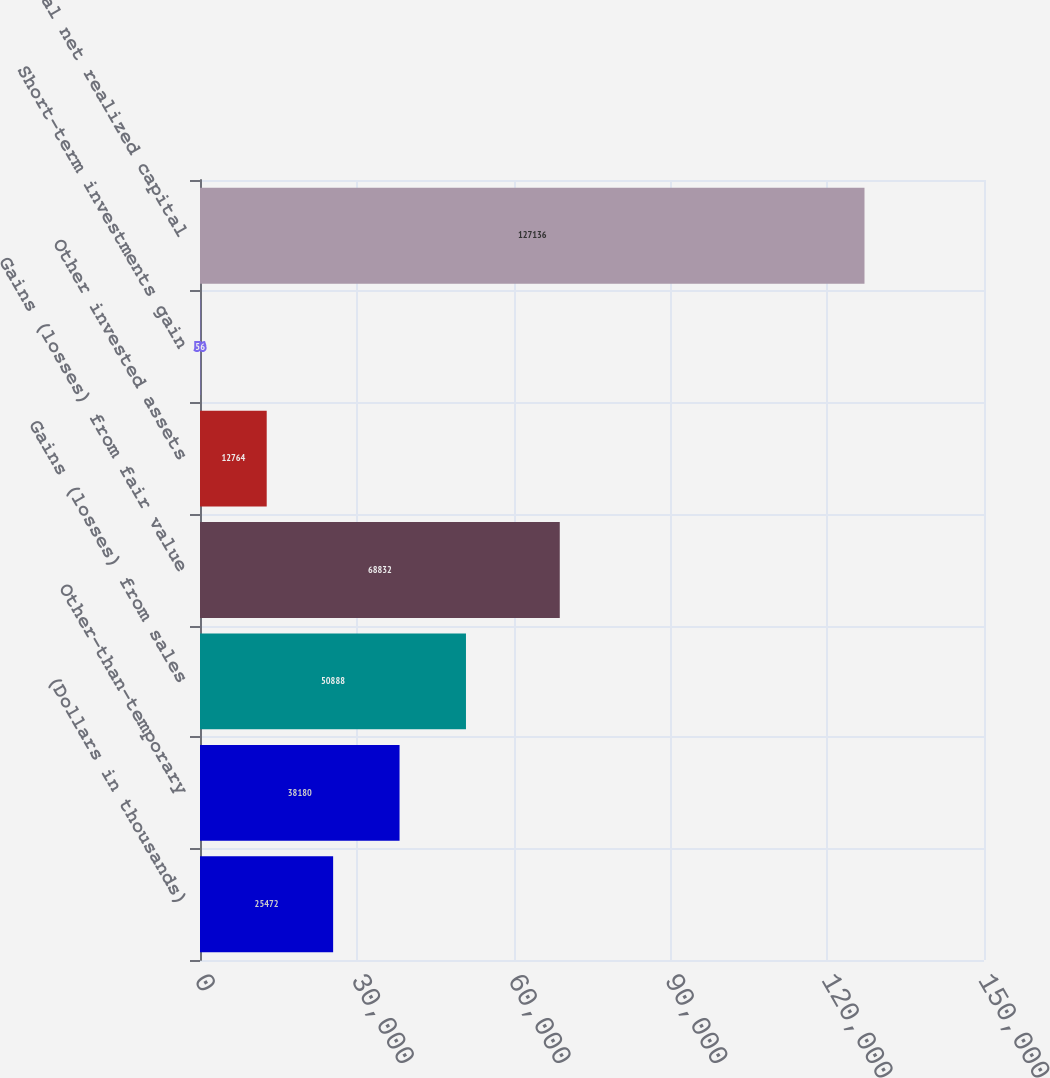Convert chart. <chart><loc_0><loc_0><loc_500><loc_500><bar_chart><fcel>(Dollars in thousands)<fcel>Other-than-temporary<fcel>Gains (losses) from sales<fcel>Gains (losses) from fair value<fcel>Other invested assets<fcel>Short-term investments gain<fcel>Total net realized capital<nl><fcel>25472<fcel>38180<fcel>50888<fcel>68832<fcel>12764<fcel>56<fcel>127136<nl></chart> 